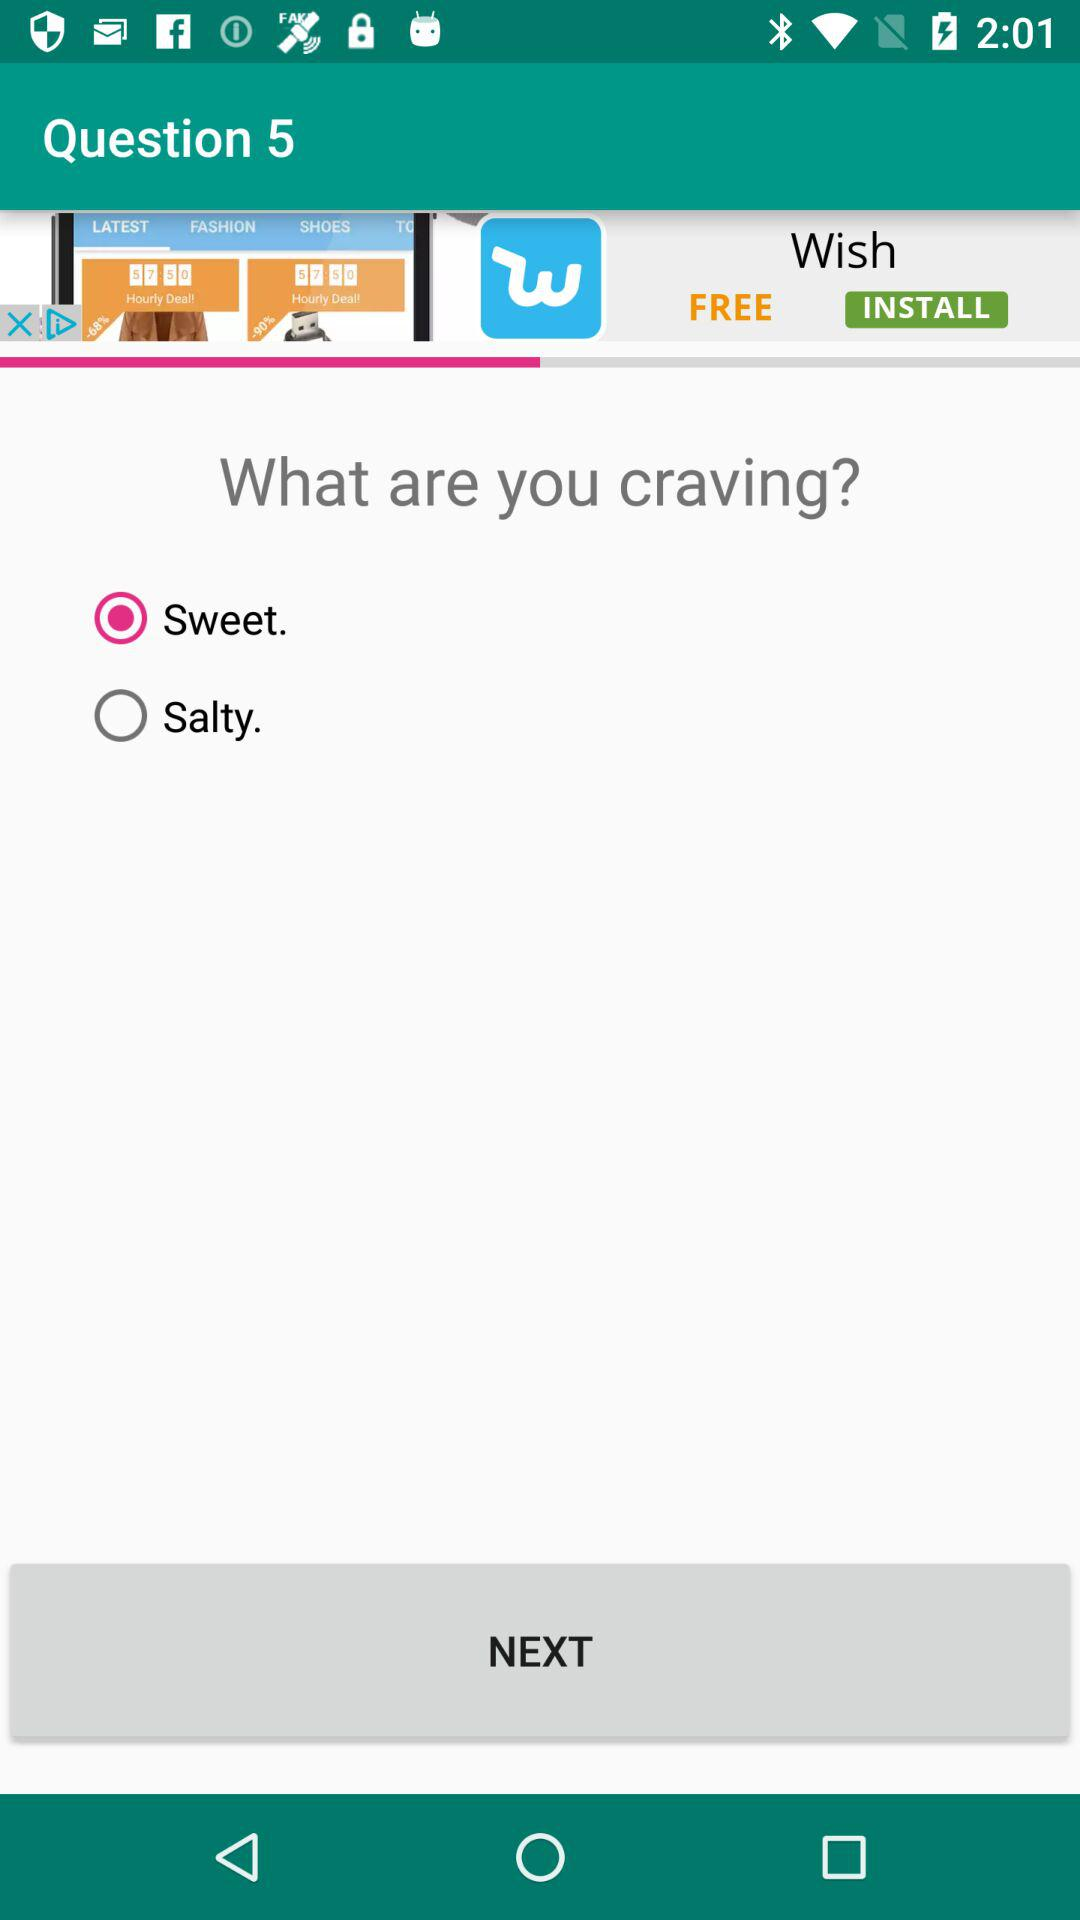Which question number is this? The question number is 5. 